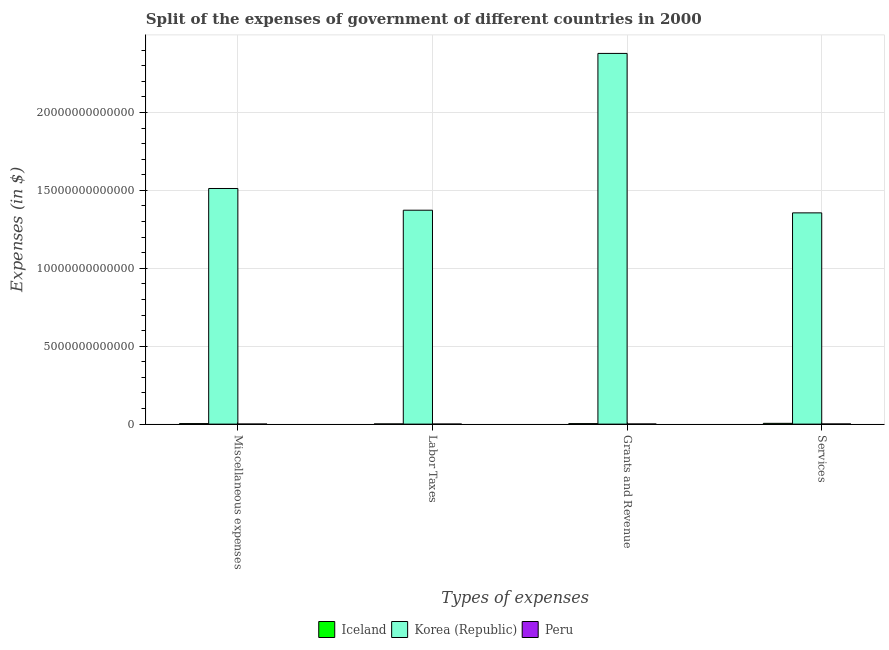How many groups of bars are there?
Make the answer very short. 4. Are the number of bars per tick equal to the number of legend labels?
Keep it short and to the point. Yes. How many bars are there on the 1st tick from the left?
Your answer should be compact. 3. What is the label of the 1st group of bars from the left?
Your answer should be very brief. Miscellaneous expenses. What is the amount spent on miscellaneous expenses in Iceland?
Your answer should be very brief. 3.17e+1. Across all countries, what is the maximum amount spent on grants and revenue?
Provide a succinct answer. 2.38e+13. Across all countries, what is the minimum amount spent on labor taxes?
Provide a short and direct response. 9.44e+08. In which country was the amount spent on services maximum?
Keep it short and to the point. Korea (Republic). In which country was the amount spent on miscellaneous expenses minimum?
Your answer should be compact. Peru. What is the total amount spent on miscellaneous expenses in the graph?
Your answer should be very brief. 1.52e+13. What is the difference between the amount spent on services in Peru and that in Iceland?
Your answer should be very brief. -4.29e+1. What is the difference between the amount spent on grants and revenue in Iceland and the amount spent on services in Korea (Republic)?
Provide a succinct answer. -1.35e+13. What is the average amount spent on labor taxes per country?
Ensure brevity in your answer.  4.58e+12. What is the difference between the amount spent on labor taxes and amount spent on miscellaneous expenses in Iceland?
Offer a very short reply. -2.13e+1. What is the ratio of the amount spent on services in Iceland to that in Peru?
Offer a terse response. 6.66. What is the difference between the highest and the second highest amount spent on services?
Provide a succinct answer. 1.35e+13. What is the difference between the highest and the lowest amount spent on grants and revenue?
Provide a short and direct response. 2.38e+13. Is the sum of the amount spent on labor taxes in Iceland and Korea (Republic) greater than the maximum amount spent on services across all countries?
Offer a terse response. Yes. What does the 3rd bar from the left in Grants and Revenue represents?
Your answer should be compact. Peru. What does the 2nd bar from the right in Grants and Revenue represents?
Ensure brevity in your answer.  Korea (Republic). How many bars are there?
Make the answer very short. 12. What is the difference between two consecutive major ticks on the Y-axis?
Offer a very short reply. 5.00e+12. How many legend labels are there?
Provide a succinct answer. 3. What is the title of the graph?
Keep it short and to the point. Split of the expenses of government of different countries in 2000. What is the label or title of the X-axis?
Make the answer very short. Types of expenses. What is the label or title of the Y-axis?
Give a very brief answer. Expenses (in $). What is the Expenses (in $) of Iceland in Miscellaneous expenses?
Give a very brief answer. 3.17e+1. What is the Expenses (in $) in Korea (Republic) in Miscellaneous expenses?
Provide a short and direct response. 1.51e+13. What is the Expenses (in $) in Peru in Miscellaneous expenses?
Offer a terse response. 1.51e+09. What is the Expenses (in $) of Iceland in Labor Taxes?
Your answer should be compact. 1.04e+1. What is the Expenses (in $) of Korea (Republic) in Labor Taxes?
Offer a terse response. 1.37e+13. What is the Expenses (in $) in Peru in Labor Taxes?
Give a very brief answer. 9.44e+08. What is the Expenses (in $) of Iceland in Grants and Revenue?
Your answer should be very brief. 2.96e+1. What is the Expenses (in $) in Korea (Republic) in Grants and Revenue?
Offer a terse response. 2.38e+13. What is the Expenses (in $) in Peru in Grants and Revenue?
Provide a short and direct response. 6.67e+09. What is the Expenses (in $) of Iceland in Services?
Offer a terse response. 5.05e+1. What is the Expenses (in $) of Korea (Republic) in Services?
Keep it short and to the point. 1.36e+13. What is the Expenses (in $) of Peru in Services?
Keep it short and to the point. 7.58e+09. Across all Types of expenses, what is the maximum Expenses (in $) of Iceland?
Provide a succinct answer. 5.05e+1. Across all Types of expenses, what is the maximum Expenses (in $) in Korea (Republic)?
Your answer should be very brief. 2.38e+13. Across all Types of expenses, what is the maximum Expenses (in $) of Peru?
Provide a short and direct response. 7.58e+09. Across all Types of expenses, what is the minimum Expenses (in $) in Iceland?
Offer a terse response. 1.04e+1. Across all Types of expenses, what is the minimum Expenses (in $) of Korea (Republic)?
Your answer should be compact. 1.36e+13. Across all Types of expenses, what is the minimum Expenses (in $) in Peru?
Your answer should be compact. 9.44e+08. What is the total Expenses (in $) in Iceland in the graph?
Keep it short and to the point. 1.22e+11. What is the total Expenses (in $) of Korea (Republic) in the graph?
Your answer should be compact. 6.62e+13. What is the total Expenses (in $) in Peru in the graph?
Give a very brief answer. 1.67e+1. What is the difference between the Expenses (in $) of Iceland in Miscellaneous expenses and that in Labor Taxes?
Give a very brief answer. 2.13e+1. What is the difference between the Expenses (in $) in Korea (Republic) in Miscellaneous expenses and that in Labor Taxes?
Your response must be concise. 1.39e+12. What is the difference between the Expenses (in $) of Peru in Miscellaneous expenses and that in Labor Taxes?
Ensure brevity in your answer.  5.67e+08. What is the difference between the Expenses (in $) of Iceland in Miscellaneous expenses and that in Grants and Revenue?
Your answer should be compact. 2.04e+09. What is the difference between the Expenses (in $) of Korea (Republic) in Miscellaneous expenses and that in Grants and Revenue?
Keep it short and to the point. -8.67e+12. What is the difference between the Expenses (in $) of Peru in Miscellaneous expenses and that in Grants and Revenue?
Offer a very short reply. -5.16e+09. What is the difference between the Expenses (in $) in Iceland in Miscellaneous expenses and that in Services?
Give a very brief answer. -1.88e+1. What is the difference between the Expenses (in $) in Korea (Republic) in Miscellaneous expenses and that in Services?
Provide a short and direct response. 1.56e+12. What is the difference between the Expenses (in $) in Peru in Miscellaneous expenses and that in Services?
Give a very brief answer. -6.07e+09. What is the difference between the Expenses (in $) in Iceland in Labor Taxes and that in Grants and Revenue?
Give a very brief answer. -1.93e+1. What is the difference between the Expenses (in $) of Korea (Republic) in Labor Taxes and that in Grants and Revenue?
Provide a succinct answer. -1.01e+13. What is the difference between the Expenses (in $) in Peru in Labor Taxes and that in Grants and Revenue?
Your answer should be very brief. -5.73e+09. What is the difference between the Expenses (in $) of Iceland in Labor Taxes and that in Services?
Ensure brevity in your answer.  -4.01e+1. What is the difference between the Expenses (in $) of Korea (Republic) in Labor Taxes and that in Services?
Give a very brief answer. 1.70e+11. What is the difference between the Expenses (in $) in Peru in Labor Taxes and that in Services?
Your response must be concise. -6.64e+09. What is the difference between the Expenses (in $) of Iceland in Grants and Revenue and that in Services?
Give a very brief answer. -2.08e+1. What is the difference between the Expenses (in $) of Korea (Republic) in Grants and Revenue and that in Services?
Offer a terse response. 1.02e+13. What is the difference between the Expenses (in $) of Peru in Grants and Revenue and that in Services?
Provide a succinct answer. -9.13e+08. What is the difference between the Expenses (in $) of Iceland in Miscellaneous expenses and the Expenses (in $) of Korea (Republic) in Labor Taxes?
Your answer should be compact. -1.37e+13. What is the difference between the Expenses (in $) in Iceland in Miscellaneous expenses and the Expenses (in $) in Peru in Labor Taxes?
Your answer should be compact. 3.07e+1. What is the difference between the Expenses (in $) in Korea (Republic) in Miscellaneous expenses and the Expenses (in $) in Peru in Labor Taxes?
Make the answer very short. 1.51e+13. What is the difference between the Expenses (in $) in Iceland in Miscellaneous expenses and the Expenses (in $) in Korea (Republic) in Grants and Revenue?
Provide a short and direct response. -2.38e+13. What is the difference between the Expenses (in $) of Iceland in Miscellaneous expenses and the Expenses (in $) of Peru in Grants and Revenue?
Give a very brief answer. 2.50e+1. What is the difference between the Expenses (in $) of Korea (Republic) in Miscellaneous expenses and the Expenses (in $) of Peru in Grants and Revenue?
Your response must be concise. 1.51e+13. What is the difference between the Expenses (in $) of Iceland in Miscellaneous expenses and the Expenses (in $) of Korea (Republic) in Services?
Your response must be concise. -1.35e+13. What is the difference between the Expenses (in $) in Iceland in Miscellaneous expenses and the Expenses (in $) in Peru in Services?
Keep it short and to the point. 2.41e+1. What is the difference between the Expenses (in $) of Korea (Republic) in Miscellaneous expenses and the Expenses (in $) of Peru in Services?
Offer a very short reply. 1.51e+13. What is the difference between the Expenses (in $) of Iceland in Labor Taxes and the Expenses (in $) of Korea (Republic) in Grants and Revenue?
Provide a short and direct response. -2.38e+13. What is the difference between the Expenses (in $) of Iceland in Labor Taxes and the Expenses (in $) of Peru in Grants and Revenue?
Offer a terse response. 3.68e+09. What is the difference between the Expenses (in $) in Korea (Republic) in Labor Taxes and the Expenses (in $) in Peru in Grants and Revenue?
Give a very brief answer. 1.37e+13. What is the difference between the Expenses (in $) of Iceland in Labor Taxes and the Expenses (in $) of Korea (Republic) in Services?
Give a very brief answer. -1.35e+13. What is the difference between the Expenses (in $) in Iceland in Labor Taxes and the Expenses (in $) in Peru in Services?
Make the answer very short. 2.77e+09. What is the difference between the Expenses (in $) in Korea (Republic) in Labor Taxes and the Expenses (in $) in Peru in Services?
Make the answer very short. 1.37e+13. What is the difference between the Expenses (in $) in Iceland in Grants and Revenue and the Expenses (in $) in Korea (Republic) in Services?
Give a very brief answer. -1.35e+13. What is the difference between the Expenses (in $) in Iceland in Grants and Revenue and the Expenses (in $) in Peru in Services?
Give a very brief answer. 2.21e+1. What is the difference between the Expenses (in $) of Korea (Republic) in Grants and Revenue and the Expenses (in $) of Peru in Services?
Give a very brief answer. 2.38e+13. What is the average Expenses (in $) of Iceland per Types of expenses?
Your response must be concise. 3.05e+1. What is the average Expenses (in $) of Korea (Republic) per Types of expenses?
Offer a very short reply. 1.65e+13. What is the average Expenses (in $) in Peru per Types of expenses?
Your answer should be very brief. 4.18e+09. What is the difference between the Expenses (in $) of Iceland and Expenses (in $) of Korea (Republic) in Miscellaneous expenses?
Offer a very short reply. -1.51e+13. What is the difference between the Expenses (in $) of Iceland and Expenses (in $) of Peru in Miscellaneous expenses?
Your answer should be compact. 3.02e+1. What is the difference between the Expenses (in $) of Korea (Republic) and Expenses (in $) of Peru in Miscellaneous expenses?
Provide a short and direct response. 1.51e+13. What is the difference between the Expenses (in $) of Iceland and Expenses (in $) of Korea (Republic) in Labor Taxes?
Make the answer very short. -1.37e+13. What is the difference between the Expenses (in $) in Iceland and Expenses (in $) in Peru in Labor Taxes?
Keep it short and to the point. 9.41e+09. What is the difference between the Expenses (in $) of Korea (Republic) and Expenses (in $) of Peru in Labor Taxes?
Make the answer very short. 1.37e+13. What is the difference between the Expenses (in $) of Iceland and Expenses (in $) of Korea (Republic) in Grants and Revenue?
Keep it short and to the point. -2.38e+13. What is the difference between the Expenses (in $) of Iceland and Expenses (in $) of Peru in Grants and Revenue?
Ensure brevity in your answer.  2.30e+1. What is the difference between the Expenses (in $) of Korea (Republic) and Expenses (in $) of Peru in Grants and Revenue?
Your answer should be very brief. 2.38e+13. What is the difference between the Expenses (in $) of Iceland and Expenses (in $) of Korea (Republic) in Services?
Keep it short and to the point. -1.35e+13. What is the difference between the Expenses (in $) of Iceland and Expenses (in $) of Peru in Services?
Offer a terse response. 4.29e+1. What is the difference between the Expenses (in $) in Korea (Republic) and Expenses (in $) in Peru in Services?
Make the answer very short. 1.35e+13. What is the ratio of the Expenses (in $) of Iceland in Miscellaneous expenses to that in Labor Taxes?
Your answer should be very brief. 3.06. What is the ratio of the Expenses (in $) of Korea (Republic) in Miscellaneous expenses to that in Labor Taxes?
Offer a terse response. 1.1. What is the ratio of the Expenses (in $) in Iceland in Miscellaneous expenses to that in Grants and Revenue?
Provide a succinct answer. 1.07. What is the ratio of the Expenses (in $) in Korea (Republic) in Miscellaneous expenses to that in Grants and Revenue?
Your answer should be compact. 0.64. What is the ratio of the Expenses (in $) in Peru in Miscellaneous expenses to that in Grants and Revenue?
Give a very brief answer. 0.23. What is the ratio of the Expenses (in $) in Iceland in Miscellaneous expenses to that in Services?
Give a very brief answer. 0.63. What is the ratio of the Expenses (in $) in Korea (Republic) in Miscellaneous expenses to that in Services?
Give a very brief answer. 1.12. What is the ratio of the Expenses (in $) of Peru in Miscellaneous expenses to that in Services?
Make the answer very short. 0.2. What is the ratio of the Expenses (in $) of Iceland in Labor Taxes to that in Grants and Revenue?
Provide a succinct answer. 0.35. What is the ratio of the Expenses (in $) in Korea (Republic) in Labor Taxes to that in Grants and Revenue?
Your response must be concise. 0.58. What is the ratio of the Expenses (in $) of Peru in Labor Taxes to that in Grants and Revenue?
Give a very brief answer. 0.14. What is the ratio of the Expenses (in $) in Iceland in Labor Taxes to that in Services?
Your answer should be compact. 0.21. What is the ratio of the Expenses (in $) in Korea (Republic) in Labor Taxes to that in Services?
Ensure brevity in your answer.  1.01. What is the ratio of the Expenses (in $) of Peru in Labor Taxes to that in Services?
Your answer should be very brief. 0.12. What is the ratio of the Expenses (in $) of Iceland in Grants and Revenue to that in Services?
Offer a very short reply. 0.59. What is the ratio of the Expenses (in $) of Korea (Republic) in Grants and Revenue to that in Services?
Your response must be concise. 1.75. What is the ratio of the Expenses (in $) in Peru in Grants and Revenue to that in Services?
Provide a short and direct response. 0.88. What is the difference between the highest and the second highest Expenses (in $) of Iceland?
Your response must be concise. 1.88e+1. What is the difference between the highest and the second highest Expenses (in $) in Korea (Republic)?
Your answer should be very brief. 8.67e+12. What is the difference between the highest and the second highest Expenses (in $) in Peru?
Your answer should be compact. 9.13e+08. What is the difference between the highest and the lowest Expenses (in $) of Iceland?
Ensure brevity in your answer.  4.01e+1. What is the difference between the highest and the lowest Expenses (in $) in Korea (Republic)?
Offer a terse response. 1.02e+13. What is the difference between the highest and the lowest Expenses (in $) in Peru?
Your answer should be very brief. 6.64e+09. 